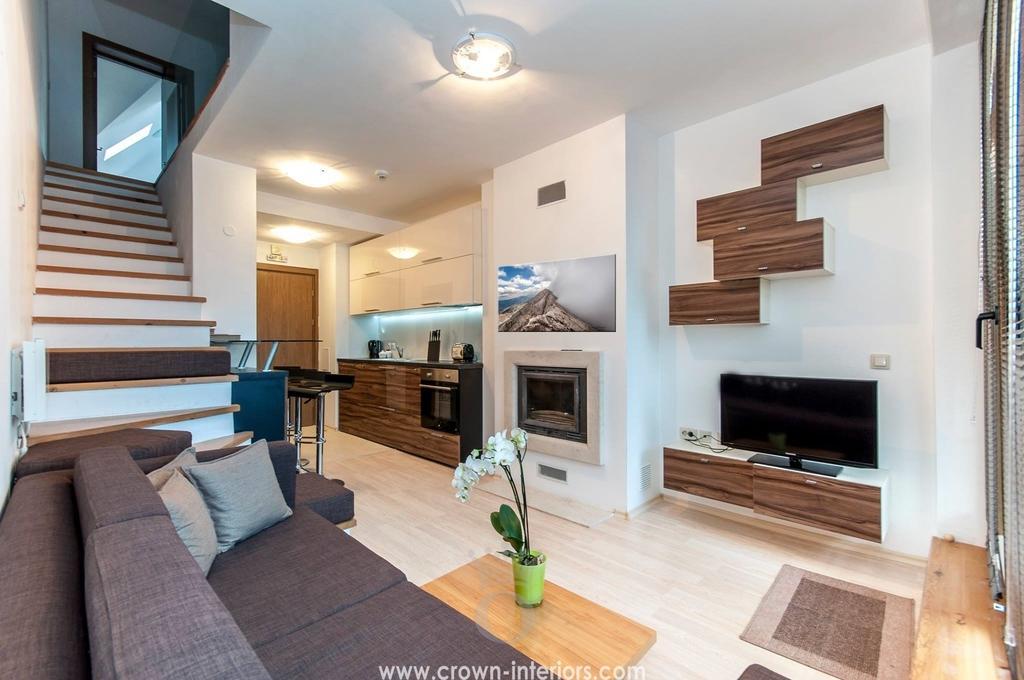Can you describe this image briefly? This picture is clicked inside the room. In the foreground we can see the cushions and a couch and we can see a flower vase placed on the top of the center table and we can see the wooden cabinets, television and some object placed on the ground and we can see there are some objects placed on the top of the wooden object which seems to be the table and we can see the stairway, roof, ceiling lights, wooden door, wall and many other objects. At the bottom we can see the text on the image. 